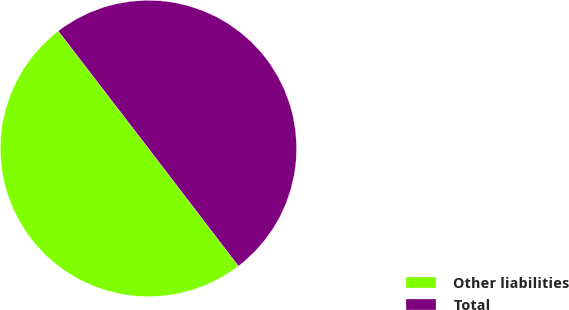Convert chart. <chart><loc_0><loc_0><loc_500><loc_500><pie_chart><fcel>Other liabilities<fcel>Total<nl><fcel>49.97%<fcel>50.03%<nl></chart> 